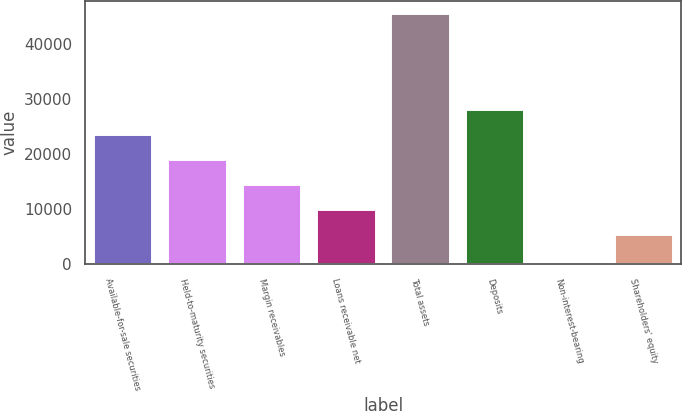Convert chart. <chart><loc_0><loc_0><loc_500><loc_500><bar_chart><fcel>Available-for-sale securities<fcel>Held-to-maturity securities<fcel>Margin receivables<fcel>Loans receivable net<fcel>Total assets<fcel>Deposits<fcel>Non-interest-bearing<fcel>Shareholders' equity<nl><fcel>23571.8<fcel>19022.6<fcel>14473.4<fcel>9924.2<fcel>45530<fcel>28121<fcel>38<fcel>5375<nl></chart> 